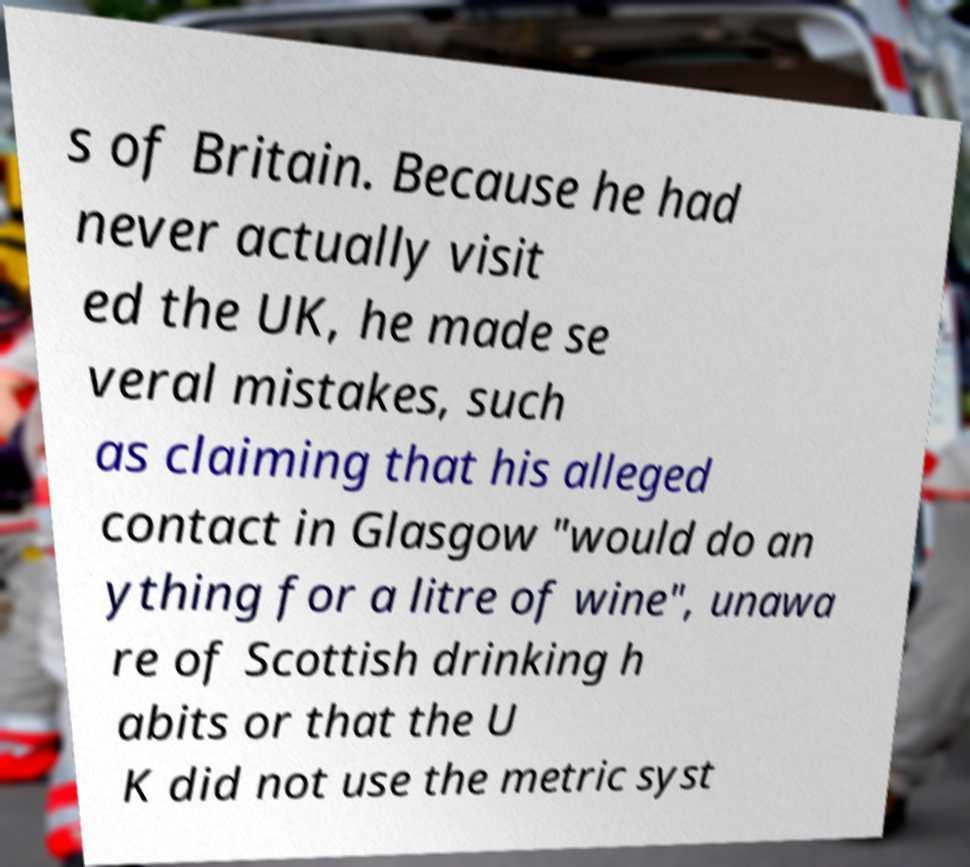There's text embedded in this image that I need extracted. Can you transcribe it verbatim? s of Britain. Because he had never actually visit ed the UK, he made se veral mistakes, such as claiming that his alleged contact in Glasgow "would do an ything for a litre of wine", unawa re of Scottish drinking h abits or that the U K did not use the metric syst 